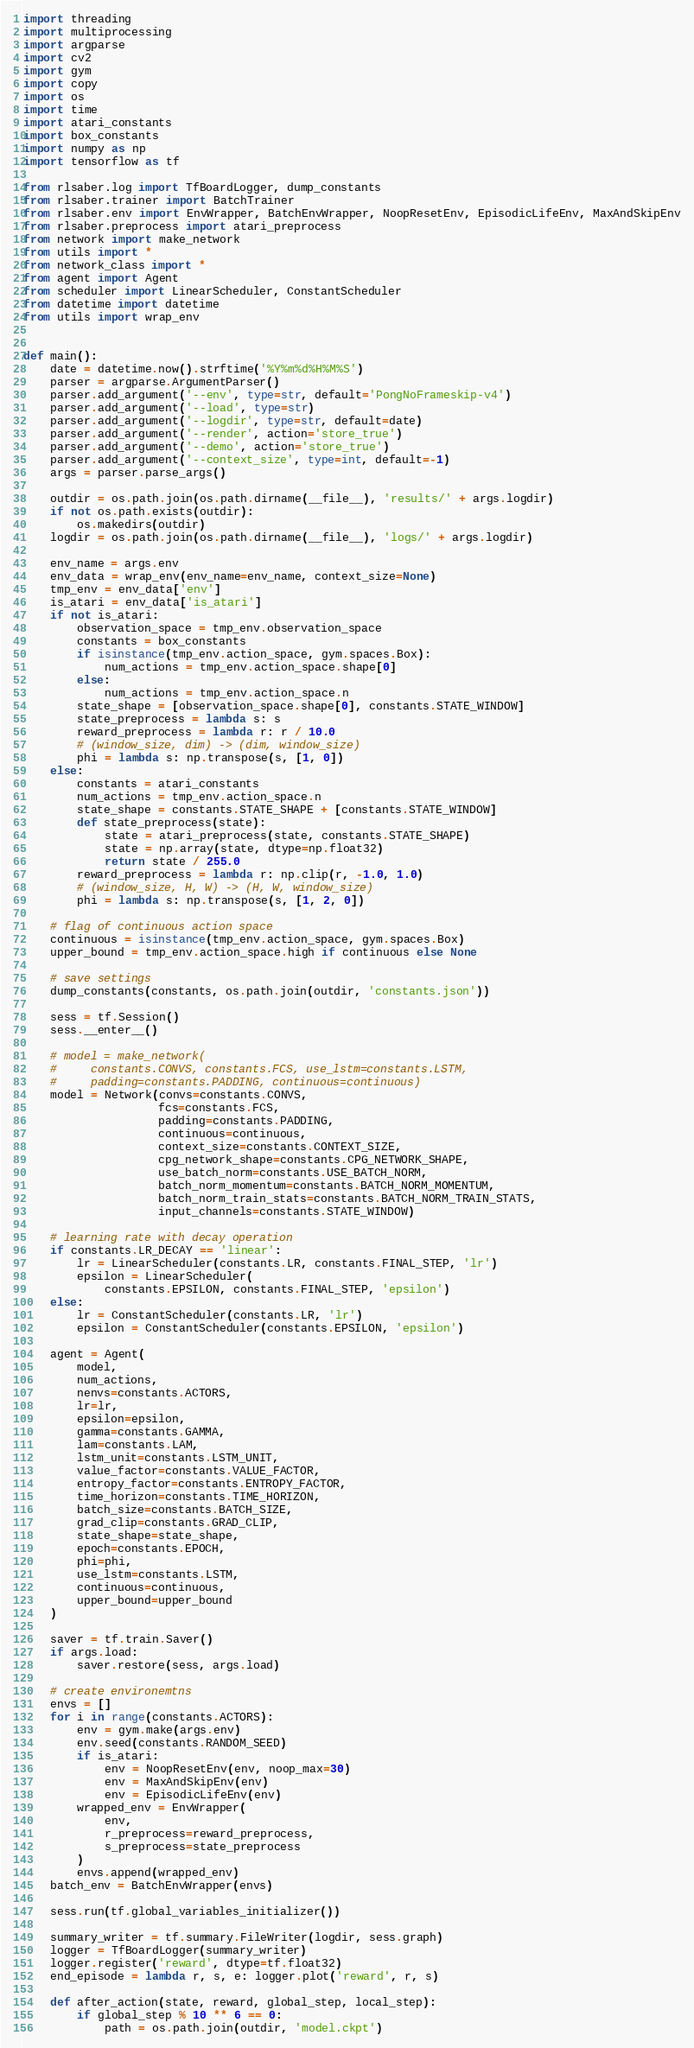Convert code to text. <code><loc_0><loc_0><loc_500><loc_500><_Python_>import threading
import multiprocessing
import argparse
import cv2
import gym
import copy
import os
import time
import atari_constants
import box_constants
import numpy as np
import tensorflow as tf

from rlsaber.log import TfBoardLogger, dump_constants
from rlsaber.trainer import BatchTrainer
from rlsaber.env import EnvWrapper, BatchEnvWrapper, NoopResetEnv, EpisodicLifeEnv, MaxAndSkipEnv
from rlsaber.preprocess import atari_preprocess
from network import make_network
from utils import *
from network_class import *
from agent import Agent
from scheduler import LinearScheduler, ConstantScheduler
from datetime import datetime
from utils import wrap_env


def main():
    date = datetime.now().strftime('%Y%m%d%H%M%S')
    parser = argparse.ArgumentParser()
    parser.add_argument('--env', type=str, default='PongNoFrameskip-v4')
    parser.add_argument('--load', type=str)
    parser.add_argument('--logdir', type=str, default=date)
    parser.add_argument('--render', action='store_true')
    parser.add_argument('--demo', action='store_true')
    parser.add_argument('--context_size', type=int, default=-1)
    args = parser.parse_args()

    outdir = os.path.join(os.path.dirname(__file__), 'results/' + args.logdir)
    if not os.path.exists(outdir):
        os.makedirs(outdir)
    logdir = os.path.join(os.path.dirname(__file__), 'logs/' + args.logdir)

    env_name = args.env
    env_data = wrap_env(env_name=env_name, context_size=None)
    tmp_env = env_data['env']
    is_atari = env_data['is_atari']
    if not is_atari:
        observation_space = tmp_env.observation_space
        constants = box_constants
        if isinstance(tmp_env.action_space, gym.spaces.Box):
            num_actions = tmp_env.action_space.shape[0]
        else:
            num_actions = tmp_env.action_space.n
        state_shape = [observation_space.shape[0], constants.STATE_WINDOW]
        state_preprocess = lambda s: s
        reward_preprocess = lambda r: r / 10.0
        # (window_size, dim) -> (dim, window_size)
        phi = lambda s: np.transpose(s, [1, 0])
    else:
        constants = atari_constants
        num_actions = tmp_env.action_space.n
        state_shape = constants.STATE_SHAPE + [constants.STATE_WINDOW]
        def state_preprocess(state):
            state = atari_preprocess(state, constants.STATE_SHAPE)
            state = np.array(state, dtype=np.float32)
            return state / 255.0
        reward_preprocess = lambda r: np.clip(r, -1.0, 1.0)
        # (window_size, H, W) -> (H, W, window_size)
        phi = lambda s: np.transpose(s, [1, 2, 0])

    # flag of continuous action space
    continuous = isinstance(tmp_env.action_space, gym.spaces.Box)
    upper_bound = tmp_env.action_space.high if continuous else None

    # save settings
    dump_constants(constants, os.path.join(outdir, 'constants.json'))

    sess = tf.Session()
    sess.__enter__()

    # model = make_network(
    #     constants.CONVS, constants.FCS, use_lstm=constants.LSTM,
    #     padding=constants.PADDING, continuous=continuous)
    model = Network(convs=constants.CONVS,
                    fcs=constants.FCS,
                    padding=constants.PADDING,
                    continuous=continuous,
                    context_size=constants.CONTEXT_SIZE,
                    cpg_network_shape=constants.CPG_NETWORK_SHAPE,
                    use_batch_norm=constants.USE_BATCH_NORM,
                    batch_norm_momentum=constants.BATCH_NORM_MOMENTUM,
                    batch_norm_train_stats=constants.BATCH_NORM_TRAIN_STATS,
                    input_channels=constants.STATE_WINDOW)

    # learning rate with decay operation
    if constants.LR_DECAY == 'linear':
        lr = LinearScheduler(constants.LR, constants.FINAL_STEP, 'lr')
        epsilon = LinearScheduler(
            constants.EPSILON, constants.FINAL_STEP, 'epsilon')
    else:
        lr = ConstantScheduler(constants.LR, 'lr')
        epsilon = ConstantScheduler(constants.EPSILON, 'epsilon')

    agent = Agent(
        model,
        num_actions,
        nenvs=constants.ACTORS,
        lr=lr,
        epsilon=epsilon,
        gamma=constants.GAMMA,
        lam=constants.LAM,
        lstm_unit=constants.LSTM_UNIT,
        value_factor=constants.VALUE_FACTOR,
        entropy_factor=constants.ENTROPY_FACTOR,
        time_horizon=constants.TIME_HORIZON,
        batch_size=constants.BATCH_SIZE,
        grad_clip=constants.GRAD_CLIP,
        state_shape=state_shape,
        epoch=constants.EPOCH,
        phi=phi,
        use_lstm=constants.LSTM,
        continuous=continuous,
        upper_bound=upper_bound
    )

    saver = tf.train.Saver()
    if args.load:
        saver.restore(sess, args.load)

    # create environemtns
    envs = []
    for i in range(constants.ACTORS):
        env = gym.make(args.env)
        env.seed(constants.RANDOM_SEED)
        if is_atari:
            env = NoopResetEnv(env, noop_max=30)
            env = MaxAndSkipEnv(env)
            env = EpisodicLifeEnv(env)
        wrapped_env = EnvWrapper(
            env,
            r_preprocess=reward_preprocess,
            s_preprocess=state_preprocess
        ) 
        envs.append(wrapped_env)
    batch_env = BatchEnvWrapper(envs)

    sess.run(tf.global_variables_initializer())

    summary_writer = tf.summary.FileWriter(logdir, sess.graph)
    logger = TfBoardLogger(summary_writer)
    logger.register('reward', dtype=tf.float32)
    end_episode = lambda r, s, e: logger.plot('reward', r, s)

    def after_action(state, reward, global_step, local_step):
        if global_step % 10 ** 6 == 0:
            path = os.path.join(outdir, 'model.ckpt')</code> 